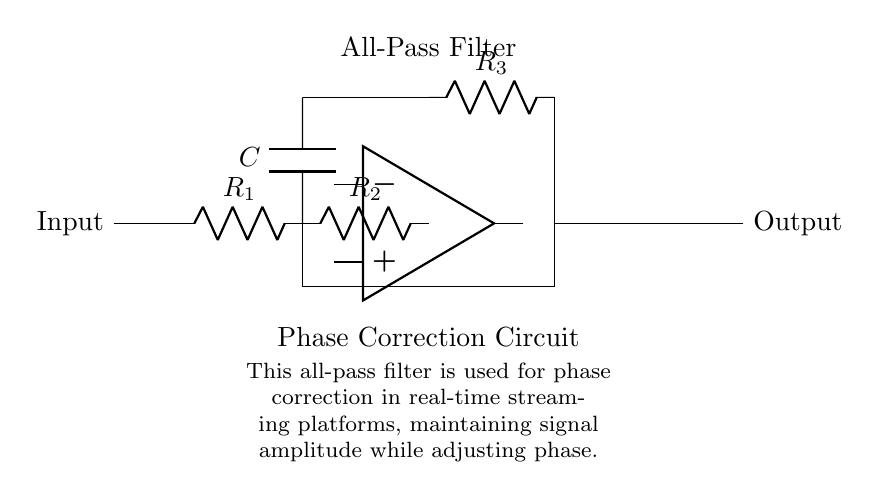What is the input of this circuit? The input of the circuit is located to the left side of the diagram, labeled as "Input."
Answer: Input What component is used to adjust the phase? The operational amplifier serves the primary role in the circuit to adjust the phase of the signal while maintaining amplitude.
Answer: Operational amplifier How many resistors are in this circuit? There are three resistors labeled as R1, R2, and R3 in the circuit.
Answer: Three What is the function of capacitor C in this circuit? Capacitor C is connected to ground and is used to introduce a phase shift, completing the all-pass filter design.
Answer: Phase shift What type of filter is represented by this circuit? The circuit is an all-pass filter, which is indicated by the label above the op amp in the diagram.
Answer: All-pass filter What is the purpose of this circuit in the context given? This circuit is specifically designed for phase correction in real-time streaming platforms, which is mentioned in the explanation at the bottom of the diagram.
Answer: Phase correction Which way does the output signal flow? The output signal flows from the right side of the circuit, indicated by the label "Output."
Answer: Right 